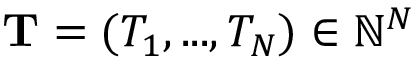Convert formula to latex. <formula><loc_0><loc_0><loc_500><loc_500>T = ( T _ { 1 } , \dots , T _ { N } ) \in \mathbb { N } ^ { N }</formula> 